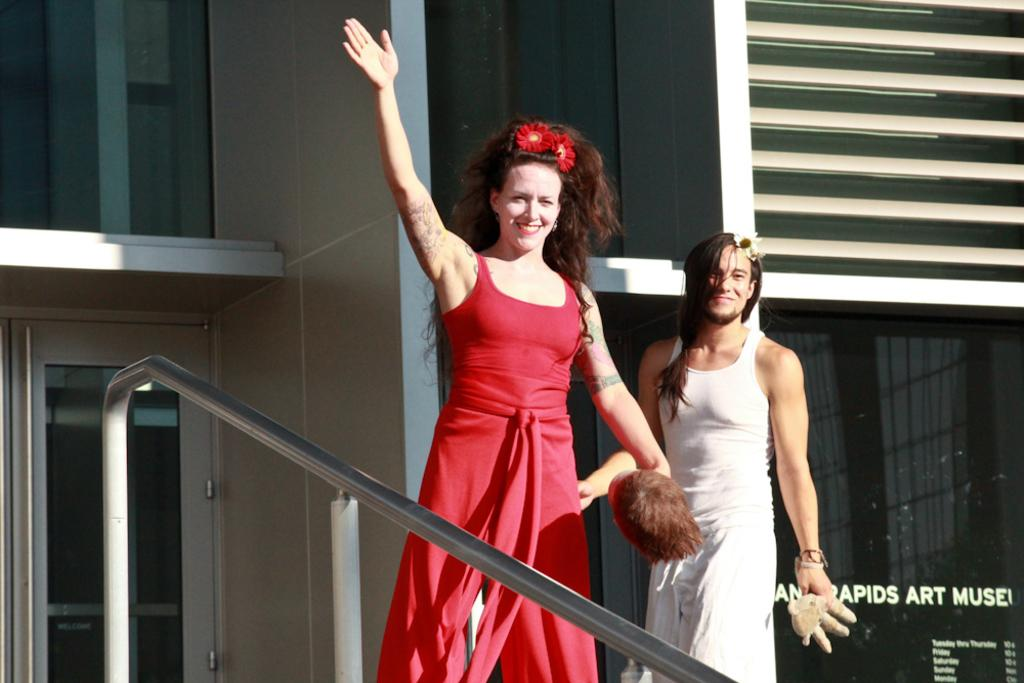How many people are in the image? There are two persons in the image. What are the persons holding in their hands? The persons are holding something in their hands, but the specific object is not mentioned in the facts. What can be seen in the background of the image? There is a building in the background of the image. What is written on the building? There is text written on the building. What part of an object can be seen in the image? There is a handle visible in the image. What type of stick is being used to plough the field in the image? There is no stick or plough present in the image. What is the best way to reach the destination shown in the image? The facts provided do not give enough information to determine the best way to reach a destination. 